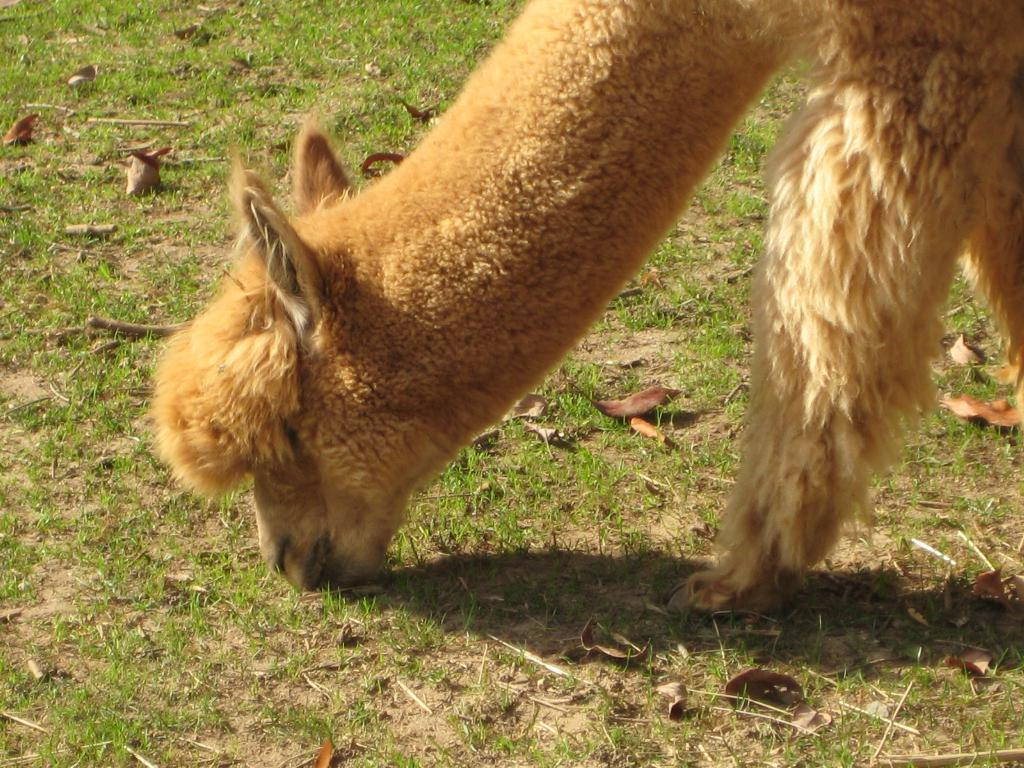What type of creature is present in the image? There is an animal in the image. What is the animal doing in the image? The animal is grazing the grass. How many birds can be seen flying in a curve in the image? There are no birds present in the image, and therefore no birds can be seen flying in a curve. What object is being smashed by the animal in the image? There is no object being smashed in the image; the animal is grazing the grass. 